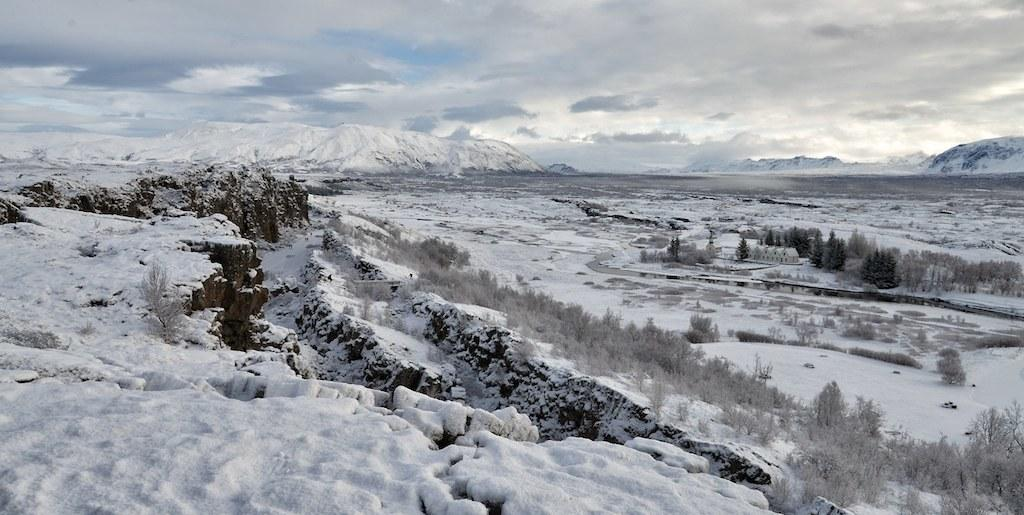What type of weather is depicted in the image? There is snow in the image, indicating cold weather. What natural elements can be seen in the image? There are trees and mountains in the image. What is visible in the background of the image? The sky is visible in the image. What type of bead is being used by the spy in the image? There is no spy or bead present in the image. What type of crib is visible in the image? There is no crib present in the image. 